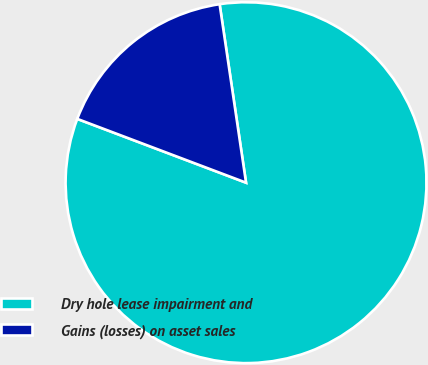<chart> <loc_0><loc_0><loc_500><loc_500><pie_chart><fcel>Dry hole lease impairment and<fcel>Gains (losses) on asset sales<nl><fcel>83.09%<fcel>16.91%<nl></chart> 